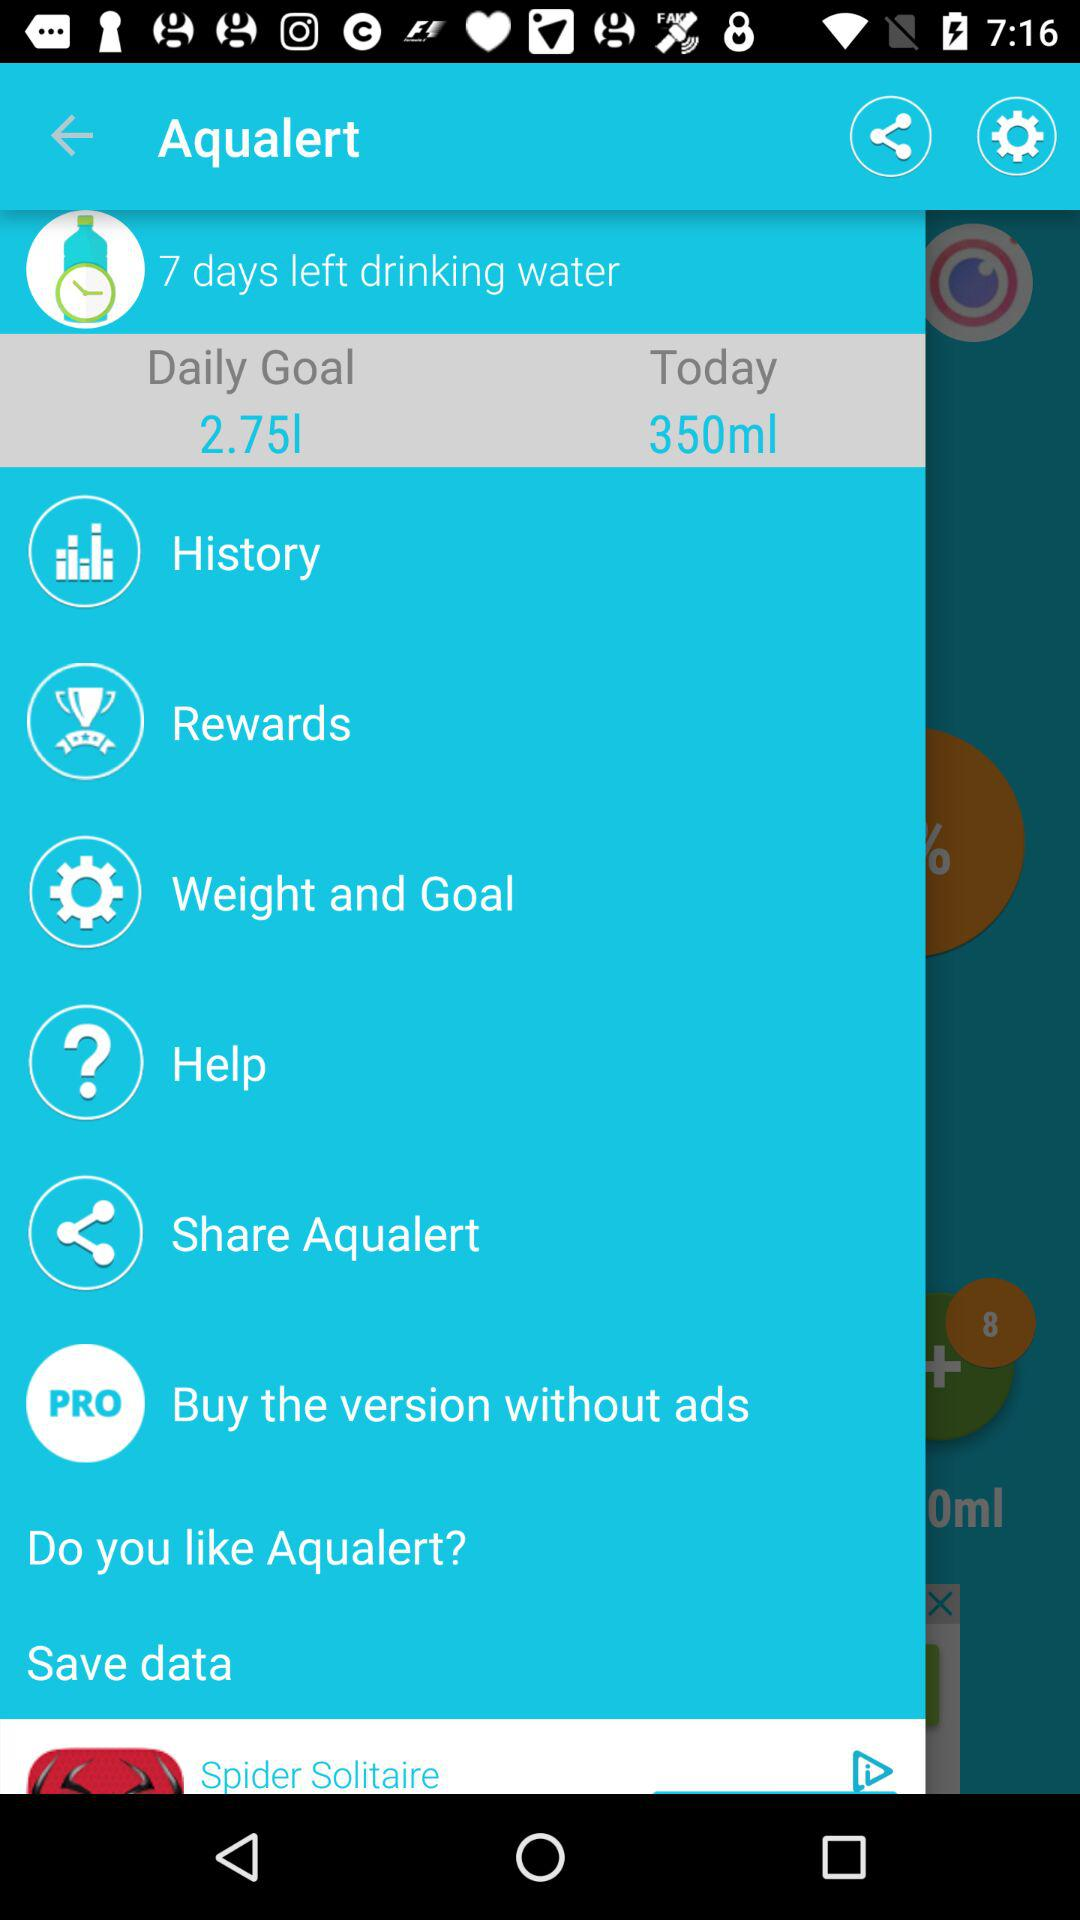What is the app name? The app name is "Aqualert". 